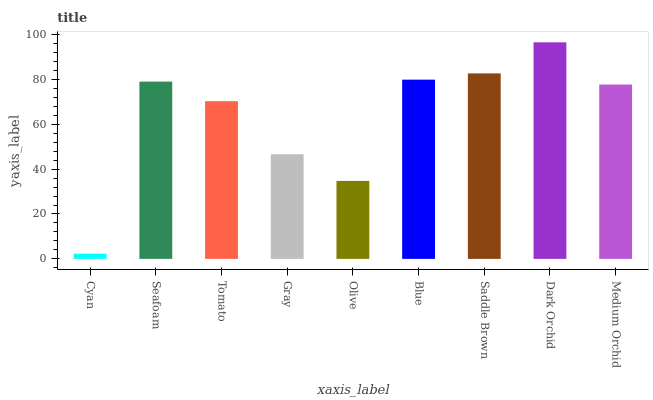Is Seafoam the minimum?
Answer yes or no. No. Is Seafoam the maximum?
Answer yes or no. No. Is Seafoam greater than Cyan?
Answer yes or no. Yes. Is Cyan less than Seafoam?
Answer yes or no. Yes. Is Cyan greater than Seafoam?
Answer yes or no. No. Is Seafoam less than Cyan?
Answer yes or no. No. Is Medium Orchid the high median?
Answer yes or no. Yes. Is Medium Orchid the low median?
Answer yes or no. Yes. Is Blue the high median?
Answer yes or no. No. Is Dark Orchid the low median?
Answer yes or no. No. 